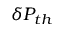Convert formula to latex. <formula><loc_0><loc_0><loc_500><loc_500>\delta P _ { t h }</formula> 